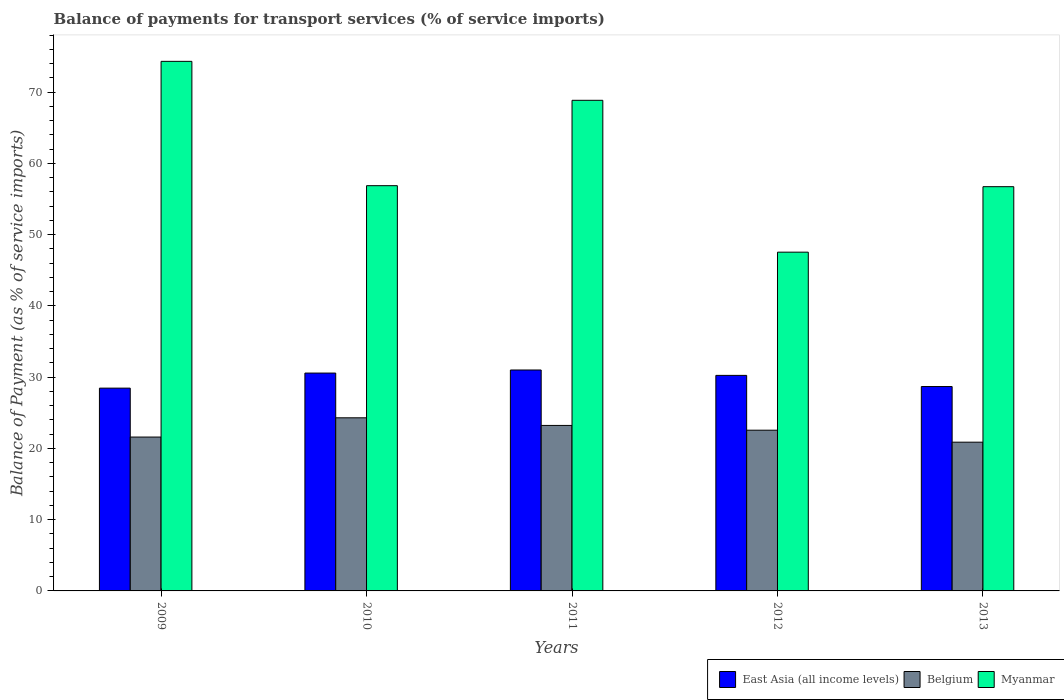How many different coloured bars are there?
Keep it short and to the point. 3. Are the number of bars per tick equal to the number of legend labels?
Keep it short and to the point. Yes. Are the number of bars on each tick of the X-axis equal?
Provide a short and direct response. Yes. How many bars are there on the 4th tick from the right?
Your answer should be compact. 3. What is the label of the 1st group of bars from the left?
Keep it short and to the point. 2009. In how many cases, is the number of bars for a given year not equal to the number of legend labels?
Provide a short and direct response. 0. What is the balance of payments for transport services in East Asia (all income levels) in 2012?
Your answer should be very brief. 30.25. Across all years, what is the maximum balance of payments for transport services in Myanmar?
Provide a short and direct response. 74.33. Across all years, what is the minimum balance of payments for transport services in Myanmar?
Your answer should be compact. 47.55. What is the total balance of payments for transport services in Myanmar in the graph?
Offer a terse response. 304.34. What is the difference between the balance of payments for transport services in Belgium in 2010 and that in 2013?
Your answer should be compact. 3.42. What is the difference between the balance of payments for transport services in Belgium in 2010 and the balance of payments for transport services in East Asia (all income levels) in 2013?
Provide a succinct answer. -4.39. What is the average balance of payments for transport services in Belgium per year?
Give a very brief answer. 22.51. In the year 2009, what is the difference between the balance of payments for transport services in Belgium and balance of payments for transport services in Myanmar?
Your answer should be very brief. -52.73. In how many years, is the balance of payments for transport services in East Asia (all income levels) greater than 60 %?
Your answer should be very brief. 0. What is the ratio of the balance of payments for transport services in Belgium in 2010 to that in 2012?
Offer a terse response. 1.08. What is the difference between the highest and the second highest balance of payments for transport services in Myanmar?
Offer a terse response. 5.47. What is the difference between the highest and the lowest balance of payments for transport services in Belgium?
Keep it short and to the point. 3.42. In how many years, is the balance of payments for transport services in East Asia (all income levels) greater than the average balance of payments for transport services in East Asia (all income levels) taken over all years?
Your response must be concise. 3. What does the 3rd bar from the left in 2011 represents?
Make the answer very short. Myanmar. Is it the case that in every year, the sum of the balance of payments for transport services in East Asia (all income levels) and balance of payments for transport services in Belgium is greater than the balance of payments for transport services in Myanmar?
Your answer should be very brief. No. Are the values on the major ticks of Y-axis written in scientific E-notation?
Your answer should be compact. No. Does the graph contain any zero values?
Ensure brevity in your answer.  No. Does the graph contain grids?
Make the answer very short. No. Where does the legend appear in the graph?
Make the answer very short. Bottom right. How many legend labels are there?
Provide a short and direct response. 3. What is the title of the graph?
Ensure brevity in your answer.  Balance of payments for transport services (% of service imports). What is the label or title of the Y-axis?
Offer a very short reply. Balance of Payment (as % of service imports). What is the Balance of Payment (as % of service imports) in East Asia (all income levels) in 2009?
Provide a short and direct response. 28.46. What is the Balance of Payment (as % of service imports) of Belgium in 2009?
Offer a terse response. 21.6. What is the Balance of Payment (as % of service imports) in Myanmar in 2009?
Offer a terse response. 74.33. What is the Balance of Payment (as % of service imports) in East Asia (all income levels) in 2010?
Provide a succinct answer. 30.58. What is the Balance of Payment (as % of service imports) of Belgium in 2010?
Give a very brief answer. 24.3. What is the Balance of Payment (as % of service imports) in Myanmar in 2010?
Your answer should be very brief. 56.88. What is the Balance of Payment (as % of service imports) of East Asia (all income levels) in 2011?
Keep it short and to the point. 31.01. What is the Balance of Payment (as % of service imports) of Belgium in 2011?
Your response must be concise. 23.23. What is the Balance of Payment (as % of service imports) of Myanmar in 2011?
Give a very brief answer. 68.86. What is the Balance of Payment (as % of service imports) of East Asia (all income levels) in 2012?
Make the answer very short. 30.25. What is the Balance of Payment (as % of service imports) in Belgium in 2012?
Provide a short and direct response. 22.56. What is the Balance of Payment (as % of service imports) in Myanmar in 2012?
Offer a terse response. 47.55. What is the Balance of Payment (as % of service imports) in East Asia (all income levels) in 2013?
Keep it short and to the point. 28.69. What is the Balance of Payment (as % of service imports) of Belgium in 2013?
Your answer should be very brief. 20.88. What is the Balance of Payment (as % of service imports) in Myanmar in 2013?
Your response must be concise. 56.74. Across all years, what is the maximum Balance of Payment (as % of service imports) of East Asia (all income levels)?
Your answer should be compact. 31.01. Across all years, what is the maximum Balance of Payment (as % of service imports) in Belgium?
Offer a terse response. 24.3. Across all years, what is the maximum Balance of Payment (as % of service imports) in Myanmar?
Offer a terse response. 74.33. Across all years, what is the minimum Balance of Payment (as % of service imports) of East Asia (all income levels)?
Ensure brevity in your answer.  28.46. Across all years, what is the minimum Balance of Payment (as % of service imports) in Belgium?
Provide a succinct answer. 20.88. Across all years, what is the minimum Balance of Payment (as % of service imports) in Myanmar?
Offer a terse response. 47.55. What is the total Balance of Payment (as % of service imports) of East Asia (all income levels) in the graph?
Provide a short and direct response. 148.98. What is the total Balance of Payment (as % of service imports) of Belgium in the graph?
Offer a very short reply. 112.56. What is the total Balance of Payment (as % of service imports) of Myanmar in the graph?
Provide a succinct answer. 304.34. What is the difference between the Balance of Payment (as % of service imports) in East Asia (all income levels) in 2009 and that in 2010?
Provide a succinct answer. -2.12. What is the difference between the Balance of Payment (as % of service imports) in Belgium in 2009 and that in 2010?
Keep it short and to the point. -2.7. What is the difference between the Balance of Payment (as % of service imports) in Myanmar in 2009 and that in 2010?
Offer a very short reply. 17.45. What is the difference between the Balance of Payment (as % of service imports) in East Asia (all income levels) in 2009 and that in 2011?
Your response must be concise. -2.55. What is the difference between the Balance of Payment (as % of service imports) in Belgium in 2009 and that in 2011?
Keep it short and to the point. -1.63. What is the difference between the Balance of Payment (as % of service imports) in Myanmar in 2009 and that in 2011?
Ensure brevity in your answer.  5.47. What is the difference between the Balance of Payment (as % of service imports) of East Asia (all income levels) in 2009 and that in 2012?
Your answer should be compact. -1.79. What is the difference between the Balance of Payment (as % of service imports) in Belgium in 2009 and that in 2012?
Your response must be concise. -0.96. What is the difference between the Balance of Payment (as % of service imports) in Myanmar in 2009 and that in 2012?
Provide a short and direct response. 26.78. What is the difference between the Balance of Payment (as % of service imports) in East Asia (all income levels) in 2009 and that in 2013?
Provide a short and direct response. -0.22. What is the difference between the Balance of Payment (as % of service imports) of Belgium in 2009 and that in 2013?
Offer a very short reply. 0.72. What is the difference between the Balance of Payment (as % of service imports) of Myanmar in 2009 and that in 2013?
Your response must be concise. 17.59. What is the difference between the Balance of Payment (as % of service imports) of East Asia (all income levels) in 2010 and that in 2011?
Make the answer very short. -0.43. What is the difference between the Balance of Payment (as % of service imports) in Belgium in 2010 and that in 2011?
Your answer should be very brief. 1.07. What is the difference between the Balance of Payment (as % of service imports) in Myanmar in 2010 and that in 2011?
Your answer should be compact. -11.98. What is the difference between the Balance of Payment (as % of service imports) in East Asia (all income levels) in 2010 and that in 2012?
Ensure brevity in your answer.  0.33. What is the difference between the Balance of Payment (as % of service imports) of Belgium in 2010 and that in 2012?
Your answer should be very brief. 1.74. What is the difference between the Balance of Payment (as % of service imports) of Myanmar in 2010 and that in 2012?
Provide a short and direct response. 9.33. What is the difference between the Balance of Payment (as % of service imports) of East Asia (all income levels) in 2010 and that in 2013?
Your answer should be very brief. 1.89. What is the difference between the Balance of Payment (as % of service imports) of Belgium in 2010 and that in 2013?
Keep it short and to the point. 3.42. What is the difference between the Balance of Payment (as % of service imports) of Myanmar in 2010 and that in 2013?
Your response must be concise. 0.14. What is the difference between the Balance of Payment (as % of service imports) in East Asia (all income levels) in 2011 and that in 2012?
Provide a succinct answer. 0.76. What is the difference between the Balance of Payment (as % of service imports) in Belgium in 2011 and that in 2012?
Provide a succinct answer. 0.67. What is the difference between the Balance of Payment (as % of service imports) of Myanmar in 2011 and that in 2012?
Provide a succinct answer. 21.31. What is the difference between the Balance of Payment (as % of service imports) in East Asia (all income levels) in 2011 and that in 2013?
Provide a succinct answer. 2.32. What is the difference between the Balance of Payment (as % of service imports) in Belgium in 2011 and that in 2013?
Offer a terse response. 2.35. What is the difference between the Balance of Payment (as % of service imports) of Myanmar in 2011 and that in 2013?
Keep it short and to the point. 12.12. What is the difference between the Balance of Payment (as % of service imports) in East Asia (all income levels) in 2012 and that in 2013?
Your answer should be compact. 1.56. What is the difference between the Balance of Payment (as % of service imports) in Belgium in 2012 and that in 2013?
Your answer should be compact. 1.68. What is the difference between the Balance of Payment (as % of service imports) in Myanmar in 2012 and that in 2013?
Offer a terse response. -9.19. What is the difference between the Balance of Payment (as % of service imports) of East Asia (all income levels) in 2009 and the Balance of Payment (as % of service imports) of Belgium in 2010?
Keep it short and to the point. 4.16. What is the difference between the Balance of Payment (as % of service imports) of East Asia (all income levels) in 2009 and the Balance of Payment (as % of service imports) of Myanmar in 2010?
Give a very brief answer. -28.41. What is the difference between the Balance of Payment (as % of service imports) of Belgium in 2009 and the Balance of Payment (as % of service imports) of Myanmar in 2010?
Provide a succinct answer. -35.28. What is the difference between the Balance of Payment (as % of service imports) of East Asia (all income levels) in 2009 and the Balance of Payment (as % of service imports) of Belgium in 2011?
Make the answer very short. 5.24. What is the difference between the Balance of Payment (as % of service imports) of East Asia (all income levels) in 2009 and the Balance of Payment (as % of service imports) of Myanmar in 2011?
Your response must be concise. -40.4. What is the difference between the Balance of Payment (as % of service imports) in Belgium in 2009 and the Balance of Payment (as % of service imports) in Myanmar in 2011?
Offer a terse response. -47.26. What is the difference between the Balance of Payment (as % of service imports) of East Asia (all income levels) in 2009 and the Balance of Payment (as % of service imports) of Belgium in 2012?
Provide a succinct answer. 5.9. What is the difference between the Balance of Payment (as % of service imports) in East Asia (all income levels) in 2009 and the Balance of Payment (as % of service imports) in Myanmar in 2012?
Ensure brevity in your answer.  -19.08. What is the difference between the Balance of Payment (as % of service imports) of Belgium in 2009 and the Balance of Payment (as % of service imports) of Myanmar in 2012?
Ensure brevity in your answer.  -25.95. What is the difference between the Balance of Payment (as % of service imports) in East Asia (all income levels) in 2009 and the Balance of Payment (as % of service imports) in Belgium in 2013?
Provide a succinct answer. 7.59. What is the difference between the Balance of Payment (as % of service imports) in East Asia (all income levels) in 2009 and the Balance of Payment (as % of service imports) in Myanmar in 2013?
Provide a short and direct response. -28.27. What is the difference between the Balance of Payment (as % of service imports) in Belgium in 2009 and the Balance of Payment (as % of service imports) in Myanmar in 2013?
Make the answer very short. -35.14. What is the difference between the Balance of Payment (as % of service imports) of East Asia (all income levels) in 2010 and the Balance of Payment (as % of service imports) of Belgium in 2011?
Your response must be concise. 7.35. What is the difference between the Balance of Payment (as % of service imports) in East Asia (all income levels) in 2010 and the Balance of Payment (as % of service imports) in Myanmar in 2011?
Ensure brevity in your answer.  -38.28. What is the difference between the Balance of Payment (as % of service imports) in Belgium in 2010 and the Balance of Payment (as % of service imports) in Myanmar in 2011?
Your response must be concise. -44.56. What is the difference between the Balance of Payment (as % of service imports) of East Asia (all income levels) in 2010 and the Balance of Payment (as % of service imports) of Belgium in 2012?
Offer a very short reply. 8.02. What is the difference between the Balance of Payment (as % of service imports) in East Asia (all income levels) in 2010 and the Balance of Payment (as % of service imports) in Myanmar in 2012?
Your answer should be compact. -16.97. What is the difference between the Balance of Payment (as % of service imports) in Belgium in 2010 and the Balance of Payment (as % of service imports) in Myanmar in 2012?
Provide a short and direct response. -23.25. What is the difference between the Balance of Payment (as % of service imports) in East Asia (all income levels) in 2010 and the Balance of Payment (as % of service imports) in Belgium in 2013?
Your response must be concise. 9.7. What is the difference between the Balance of Payment (as % of service imports) in East Asia (all income levels) in 2010 and the Balance of Payment (as % of service imports) in Myanmar in 2013?
Your answer should be compact. -26.16. What is the difference between the Balance of Payment (as % of service imports) of Belgium in 2010 and the Balance of Payment (as % of service imports) of Myanmar in 2013?
Keep it short and to the point. -32.44. What is the difference between the Balance of Payment (as % of service imports) of East Asia (all income levels) in 2011 and the Balance of Payment (as % of service imports) of Belgium in 2012?
Ensure brevity in your answer.  8.45. What is the difference between the Balance of Payment (as % of service imports) in East Asia (all income levels) in 2011 and the Balance of Payment (as % of service imports) in Myanmar in 2012?
Provide a succinct answer. -16.54. What is the difference between the Balance of Payment (as % of service imports) of Belgium in 2011 and the Balance of Payment (as % of service imports) of Myanmar in 2012?
Keep it short and to the point. -24.32. What is the difference between the Balance of Payment (as % of service imports) in East Asia (all income levels) in 2011 and the Balance of Payment (as % of service imports) in Belgium in 2013?
Ensure brevity in your answer.  10.13. What is the difference between the Balance of Payment (as % of service imports) in East Asia (all income levels) in 2011 and the Balance of Payment (as % of service imports) in Myanmar in 2013?
Provide a short and direct response. -25.73. What is the difference between the Balance of Payment (as % of service imports) of Belgium in 2011 and the Balance of Payment (as % of service imports) of Myanmar in 2013?
Make the answer very short. -33.51. What is the difference between the Balance of Payment (as % of service imports) of East Asia (all income levels) in 2012 and the Balance of Payment (as % of service imports) of Belgium in 2013?
Ensure brevity in your answer.  9.38. What is the difference between the Balance of Payment (as % of service imports) in East Asia (all income levels) in 2012 and the Balance of Payment (as % of service imports) in Myanmar in 2013?
Give a very brief answer. -26.48. What is the difference between the Balance of Payment (as % of service imports) in Belgium in 2012 and the Balance of Payment (as % of service imports) in Myanmar in 2013?
Offer a very short reply. -34.18. What is the average Balance of Payment (as % of service imports) in East Asia (all income levels) per year?
Offer a terse response. 29.8. What is the average Balance of Payment (as % of service imports) in Belgium per year?
Keep it short and to the point. 22.51. What is the average Balance of Payment (as % of service imports) in Myanmar per year?
Give a very brief answer. 60.87. In the year 2009, what is the difference between the Balance of Payment (as % of service imports) of East Asia (all income levels) and Balance of Payment (as % of service imports) of Belgium?
Keep it short and to the point. 6.87. In the year 2009, what is the difference between the Balance of Payment (as % of service imports) of East Asia (all income levels) and Balance of Payment (as % of service imports) of Myanmar?
Provide a short and direct response. -45.86. In the year 2009, what is the difference between the Balance of Payment (as % of service imports) in Belgium and Balance of Payment (as % of service imports) in Myanmar?
Offer a very short reply. -52.73. In the year 2010, what is the difference between the Balance of Payment (as % of service imports) of East Asia (all income levels) and Balance of Payment (as % of service imports) of Belgium?
Make the answer very short. 6.28. In the year 2010, what is the difference between the Balance of Payment (as % of service imports) in East Asia (all income levels) and Balance of Payment (as % of service imports) in Myanmar?
Give a very brief answer. -26.3. In the year 2010, what is the difference between the Balance of Payment (as % of service imports) of Belgium and Balance of Payment (as % of service imports) of Myanmar?
Your answer should be very brief. -32.58. In the year 2011, what is the difference between the Balance of Payment (as % of service imports) of East Asia (all income levels) and Balance of Payment (as % of service imports) of Belgium?
Offer a terse response. 7.78. In the year 2011, what is the difference between the Balance of Payment (as % of service imports) in East Asia (all income levels) and Balance of Payment (as % of service imports) in Myanmar?
Your answer should be compact. -37.85. In the year 2011, what is the difference between the Balance of Payment (as % of service imports) in Belgium and Balance of Payment (as % of service imports) in Myanmar?
Ensure brevity in your answer.  -45.63. In the year 2012, what is the difference between the Balance of Payment (as % of service imports) in East Asia (all income levels) and Balance of Payment (as % of service imports) in Belgium?
Your response must be concise. 7.69. In the year 2012, what is the difference between the Balance of Payment (as % of service imports) in East Asia (all income levels) and Balance of Payment (as % of service imports) in Myanmar?
Your response must be concise. -17.29. In the year 2012, what is the difference between the Balance of Payment (as % of service imports) in Belgium and Balance of Payment (as % of service imports) in Myanmar?
Your response must be concise. -24.99. In the year 2013, what is the difference between the Balance of Payment (as % of service imports) of East Asia (all income levels) and Balance of Payment (as % of service imports) of Belgium?
Your answer should be very brief. 7.81. In the year 2013, what is the difference between the Balance of Payment (as % of service imports) in East Asia (all income levels) and Balance of Payment (as % of service imports) in Myanmar?
Offer a terse response. -28.05. In the year 2013, what is the difference between the Balance of Payment (as % of service imports) of Belgium and Balance of Payment (as % of service imports) of Myanmar?
Provide a succinct answer. -35.86. What is the ratio of the Balance of Payment (as % of service imports) of East Asia (all income levels) in 2009 to that in 2010?
Give a very brief answer. 0.93. What is the ratio of the Balance of Payment (as % of service imports) of Belgium in 2009 to that in 2010?
Provide a short and direct response. 0.89. What is the ratio of the Balance of Payment (as % of service imports) in Myanmar in 2009 to that in 2010?
Provide a short and direct response. 1.31. What is the ratio of the Balance of Payment (as % of service imports) in East Asia (all income levels) in 2009 to that in 2011?
Keep it short and to the point. 0.92. What is the ratio of the Balance of Payment (as % of service imports) in Belgium in 2009 to that in 2011?
Offer a terse response. 0.93. What is the ratio of the Balance of Payment (as % of service imports) in Myanmar in 2009 to that in 2011?
Give a very brief answer. 1.08. What is the ratio of the Balance of Payment (as % of service imports) in East Asia (all income levels) in 2009 to that in 2012?
Provide a succinct answer. 0.94. What is the ratio of the Balance of Payment (as % of service imports) in Belgium in 2009 to that in 2012?
Offer a terse response. 0.96. What is the ratio of the Balance of Payment (as % of service imports) of Myanmar in 2009 to that in 2012?
Offer a terse response. 1.56. What is the ratio of the Balance of Payment (as % of service imports) of Belgium in 2009 to that in 2013?
Your answer should be compact. 1.03. What is the ratio of the Balance of Payment (as % of service imports) in Myanmar in 2009 to that in 2013?
Your answer should be compact. 1.31. What is the ratio of the Balance of Payment (as % of service imports) in East Asia (all income levels) in 2010 to that in 2011?
Provide a short and direct response. 0.99. What is the ratio of the Balance of Payment (as % of service imports) in Belgium in 2010 to that in 2011?
Keep it short and to the point. 1.05. What is the ratio of the Balance of Payment (as % of service imports) in Myanmar in 2010 to that in 2011?
Your answer should be compact. 0.83. What is the ratio of the Balance of Payment (as % of service imports) of East Asia (all income levels) in 2010 to that in 2012?
Provide a succinct answer. 1.01. What is the ratio of the Balance of Payment (as % of service imports) of Belgium in 2010 to that in 2012?
Provide a succinct answer. 1.08. What is the ratio of the Balance of Payment (as % of service imports) of Myanmar in 2010 to that in 2012?
Your response must be concise. 1.2. What is the ratio of the Balance of Payment (as % of service imports) of East Asia (all income levels) in 2010 to that in 2013?
Your response must be concise. 1.07. What is the ratio of the Balance of Payment (as % of service imports) in Belgium in 2010 to that in 2013?
Ensure brevity in your answer.  1.16. What is the ratio of the Balance of Payment (as % of service imports) of East Asia (all income levels) in 2011 to that in 2012?
Provide a succinct answer. 1.02. What is the ratio of the Balance of Payment (as % of service imports) of Belgium in 2011 to that in 2012?
Ensure brevity in your answer.  1.03. What is the ratio of the Balance of Payment (as % of service imports) of Myanmar in 2011 to that in 2012?
Your response must be concise. 1.45. What is the ratio of the Balance of Payment (as % of service imports) of East Asia (all income levels) in 2011 to that in 2013?
Provide a succinct answer. 1.08. What is the ratio of the Balance of Payment (as % of service imports) of Belgium in 2011 to that in 2013?
Ensure brevity in your answer.  1.11. What is the ratio of the Balance of Payment (as % of service imports) of Myanmar in 2011 to that in 2013?
Ensure brevity in your answer.  1.21. What is the ratio of the Balance of Payment (as % of service imports) of East Asia (all income levels) in 2012 to that in 2013?
Your answer should be compact. 1.05. What is the ratio of the Balance of Payment (as % of service imports) in Belgium in 2012 to that in 2013?
Make the answer very short. 1.08. What is the ratio of the Balance of Payment (as % of service imports) in Myanmar in 2012 to that in 2013?
Your answer should be very brief. 0.84. What is the difference between the highest and the second highest Balance of Payment (as % of service imports) of East Asia (all income levels)?
Keep it short and to the point. 0.43. What is the difference between the highest and the second highest Balance of Payment (as % of service imports) in Belgium?
Your answer should be very brief. 1.07. What is the difference between the highest and the second highest Balance of Payment (as % of service imports) of Myanmar?
Offer a very short reply. 5.47. What is the difference between the highest and the lowest Balance of Payment (as % of service imports) in East Asia (all income levels)?
Offer a terse response. 2.55. What is the difference between the highest and the lowest Balance of Payment (as % of service imports) of Belgium?
Offer a terse response. 3.42. What is the difference between the highest and the lowest Balance of Payment (as % of service imports) in Myanmar?
Your answer should be compact. 26.78. 